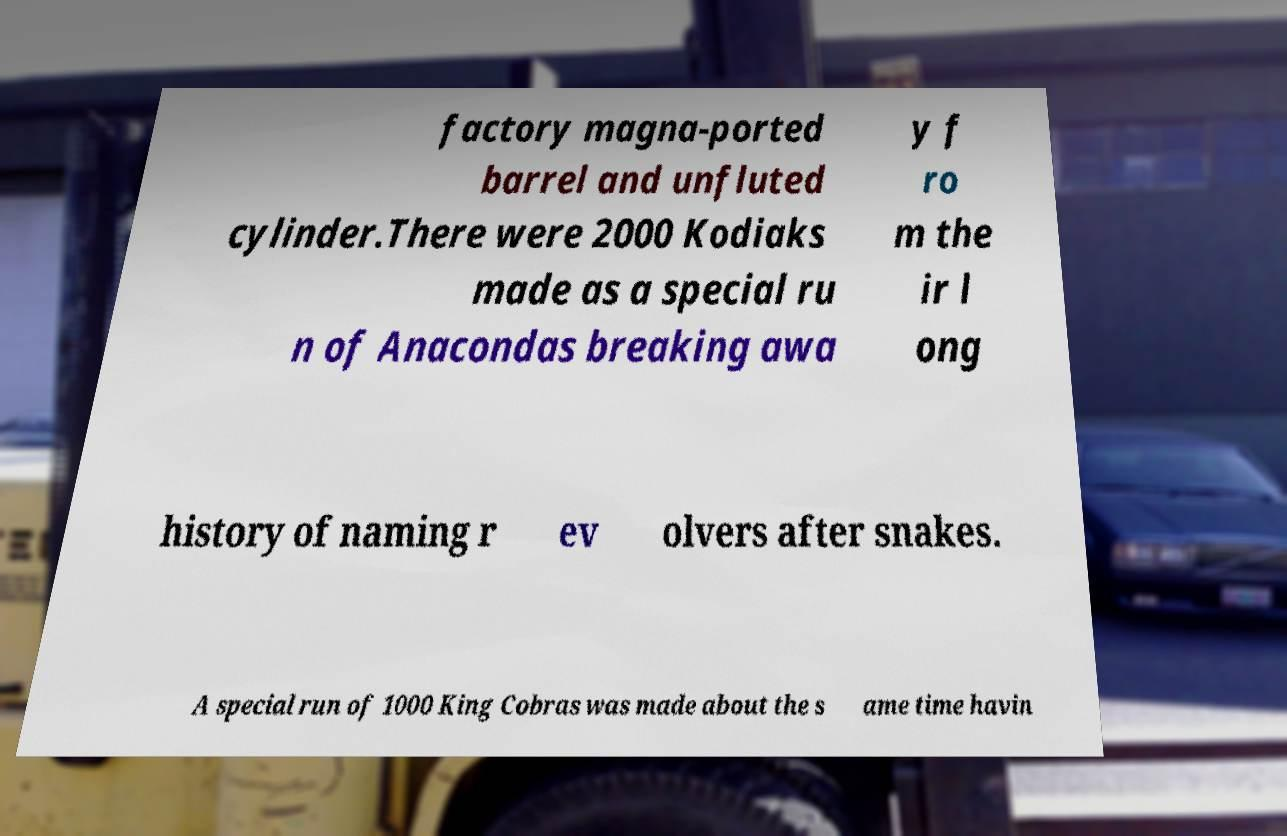There's text embedded in this image that I need extracted. Can you transcribe it verbatim? factory magna-ported barrel and unfluted cylinder.There were 2000 Kodiaks made as a special ru n of Anacondas breaking awa y f ro m the ir l ong history of naming r ev olvers after snakes. A special run of 1000 King Cobras was made about the s ame time havin 